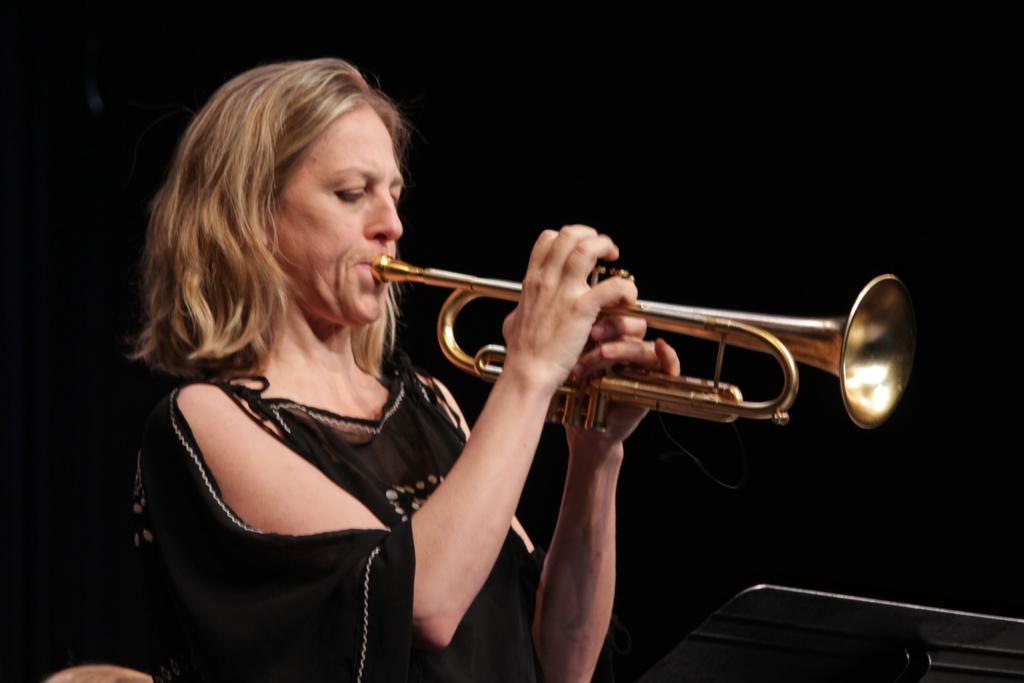Could you give a brief overview of what you see in this image? In this image there is a woman playing a musical instrument, in the bottom right there is a pad, in the background it is dark. 